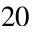Convert formula to latex. <formula><loc_0><loc_0><loc_500><loc_500>2 0</formula> 